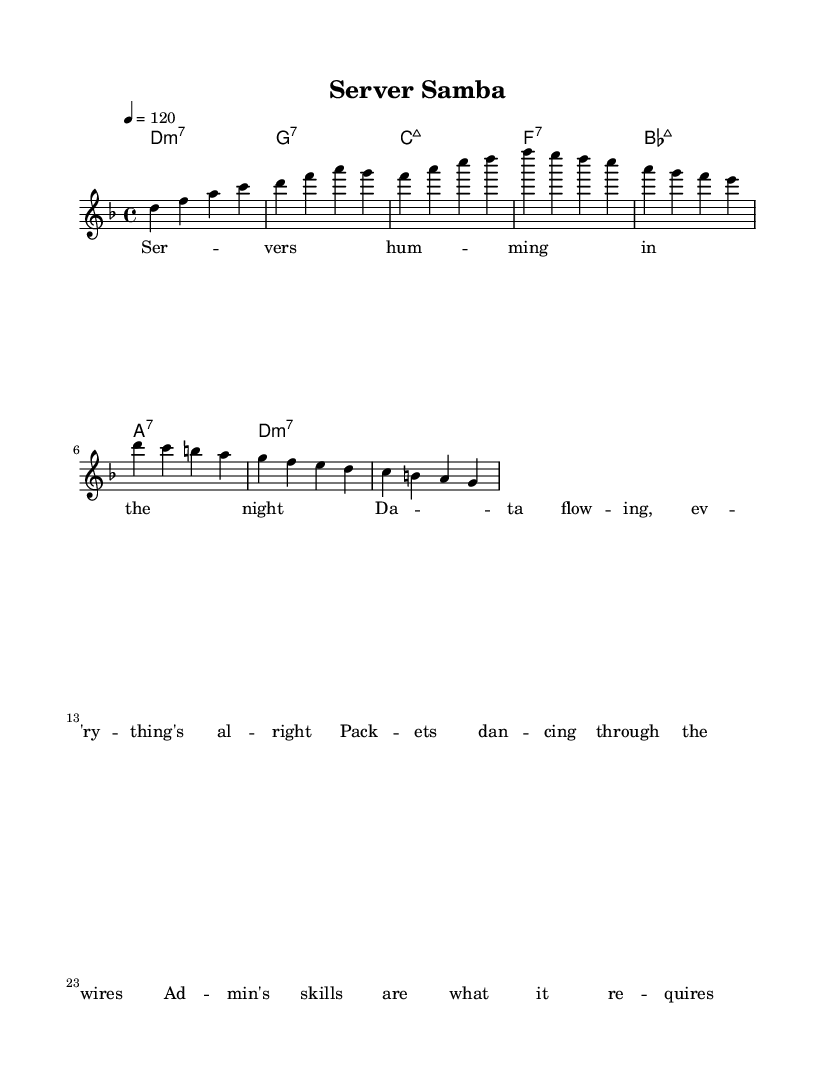What is the key signature of this music? The key signature is D minor, which is indicated by the presence of one flat (B flat) and the overall tonal structure of the melody that revolves around the D note.
Answer: D minor What is the time signature of this piece? The time signature is 4/4, as indicated at the beginning of the score, which shows that there are four beats in each measure and the quarter note gets one beat.
Answer: 4/4 What is the tempo marking for this music? The tempo marking is 120 beats per minute, represented by "4 = 120," indicating the number of beats per minute for the quarter note.
Answer: 120 How many measures are there in the melody section? Counting the measures in the melody section, there are eight measures present that correspond to the phrasing of the melody provided.
Answer: 8 What type of seventh chord is in measure 1? In measure 1, it is a D minor seventh chord, indicated by the "d1:m7" chord symbol, which specifies the root note D with a minor triad and a minor seventh above it.
Answer: D minor seventh Which chord follows the A note in the chorus hook? The chord following the A note in the chorus hook is an A seventh chord, as indicated in the chord progression after the A note in that section, showing the harmonic context.
Answer: A seventh What theme do the lyrics of this piece convey? The lyrics convey a theme of server administration and data management, focusing on the activity and skills required in the context of computer networking, as seen in phrases like "data flowing" and "admin's skills."
Answer: Server administration 